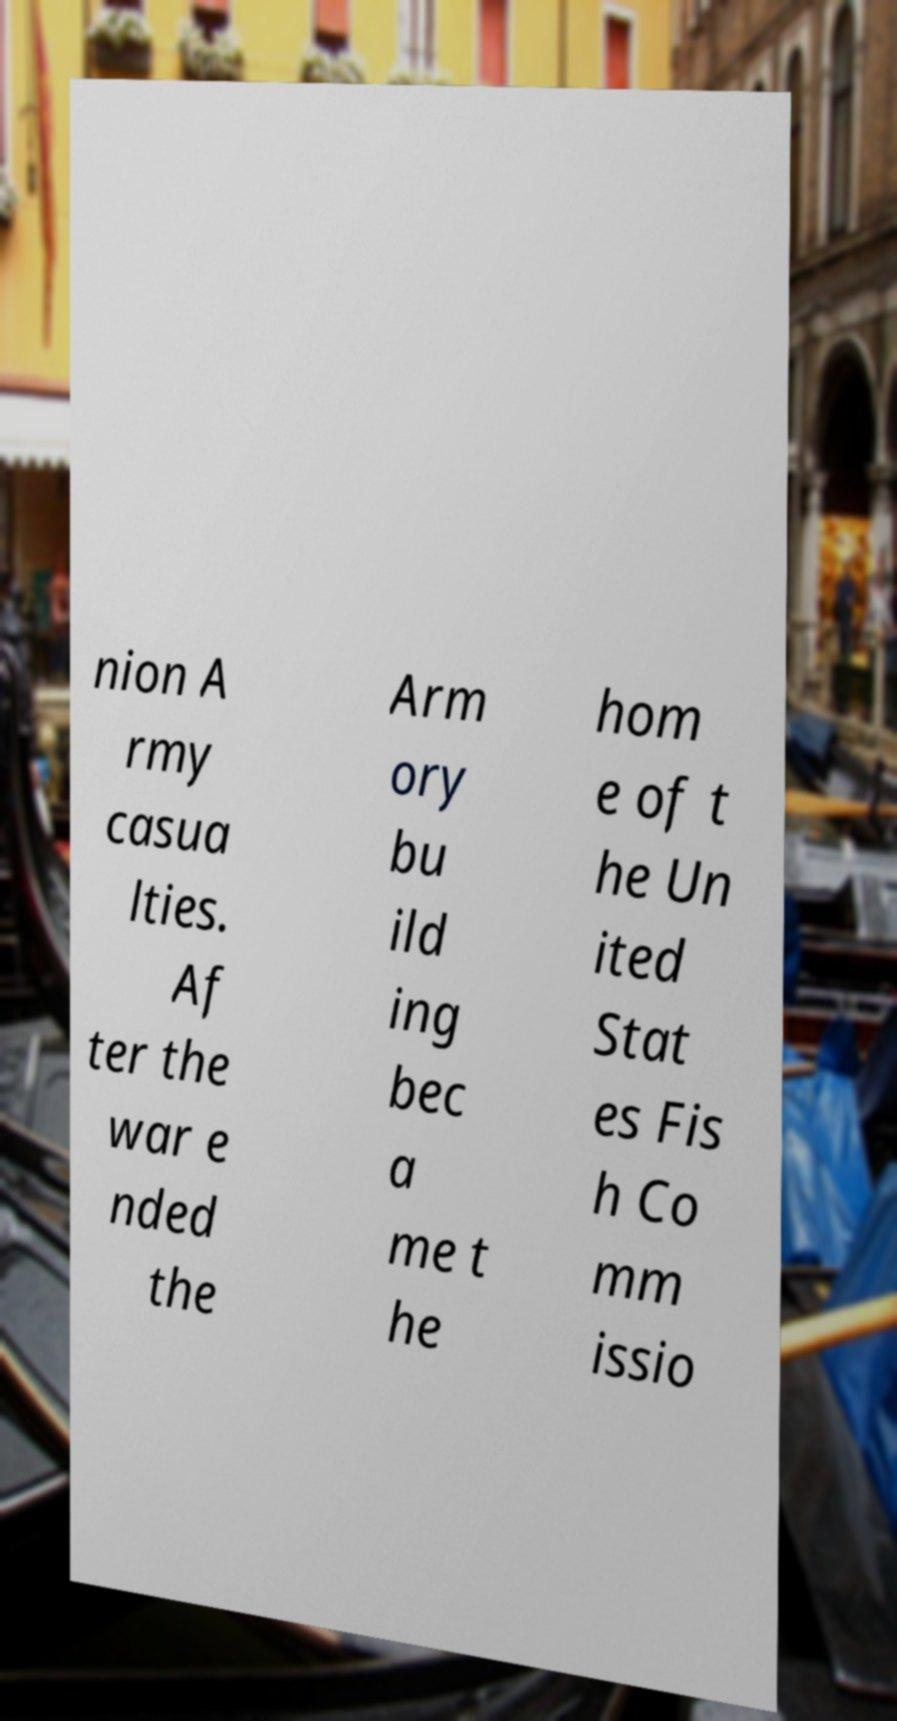Can you read and provide the text displayed in the image?This photo seems to have some interesting text. Can you extract and type it out for me? nion A rmy casua lties. Af ter the war e nded the Arm ory bu ild ing bec a me t he hom e of t he Un ited Stat es Fis h Co mm issio 